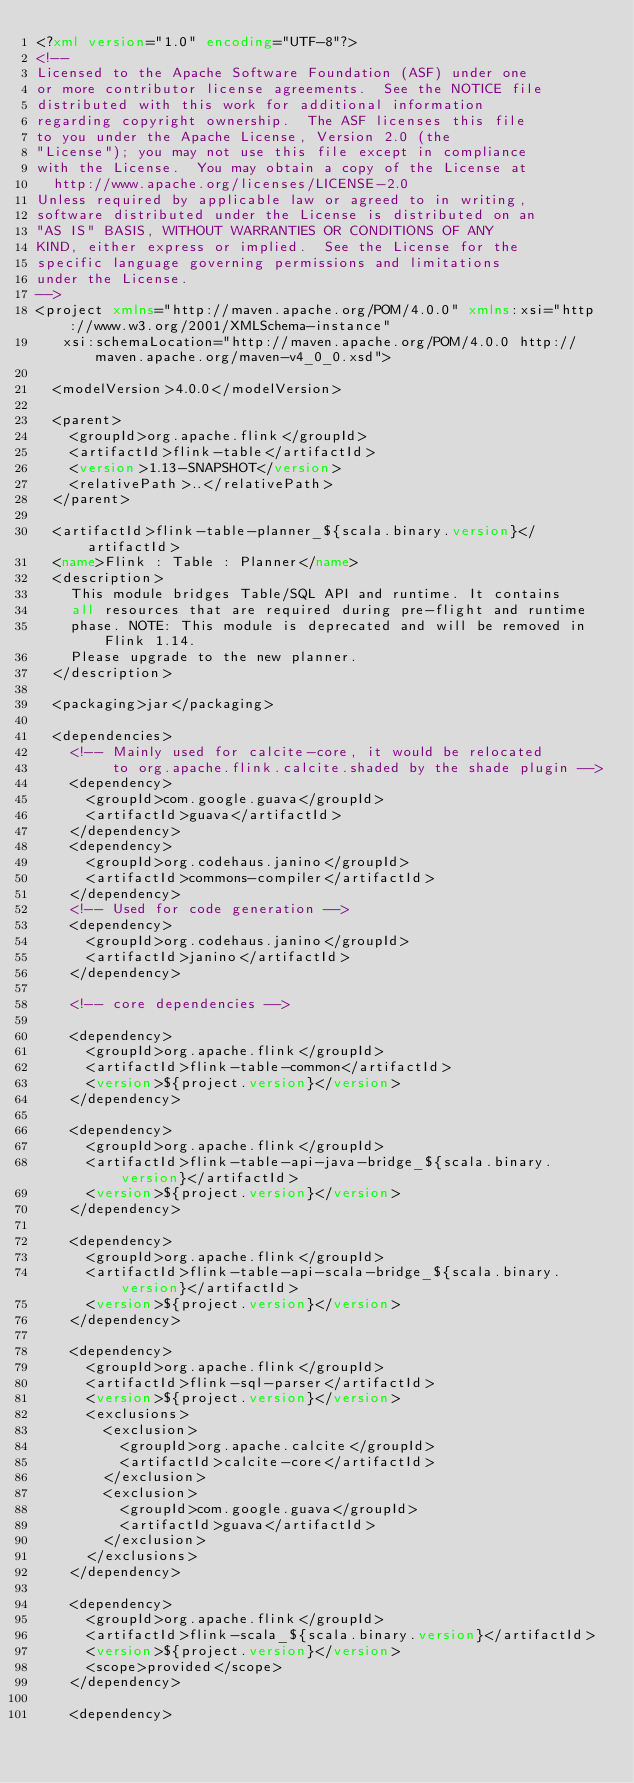<code> <loc_0><loc_0><loc_500><loc_500><_XML_><?xml version="1.0" encoding="UTF-8"?>
<!--
Licensed to the Apache Software Foundation (ASF) under one
or more contributor license agreements.  See the NOTICE file
distributed with this work for additional information
regarding copyright ownership.  The ASF licenses this file
to you under the Apache License, Version 2.0 (the
"License"); you may not use this file except in compliance
with the License.  You may obtain a copy of the License at
  http://www.apache.org/licenses/LICENSE-2.0
Unless required by applicable law or agreed to in writing,
software distributed under the License is distributed on an
"AS IS" BASIS, WITHOUT WARRANTIES OR CONDITIONS OF ANY
KIND, either express or implied.  See the License for the
specific language governing permissions and limitations
under the License.
-->
<project xmlns="http://maven.apache.org/POM/4.0.0" xmlns:xsi="http://www.w3.org/2001/XMLSchema-instance"
	 xsi:schemaLocation="http://maven.apache.org/POM/4.0.0 http://maven.apache.org/maven-v4_0_0.xsd">

	<modelVersion>4.0.0</modelVersion>

	<parent>
		<groupId>org.apache.flink</groupId>
		<artifactId>flink-table</artifactId>
		<version>1.13-SNAPSHOT</version>
		<relativePath>..</relativePath>
	</parent>

	<artifactId>flink-table-planner_${scala.binary.version}</artifactId>
	<name>Flink : Table : Planner</name>
	<description>
		This module bridges Table/SQL API and runtime. It contains
		all resources that are required during pre-flight and runtime
		phase. NOTE: This module is deprecated and will be removed in Flink 1.14.
		Please upgrade to the new planner.
	</description>

	<packaging>jar</packaging>

	<dependencies>
		<!-- Mainly used for calcite-core, it would be relocated
		     to org.apache.flink.calcite.shaded by the shade plugin -->
		<dependency>
			<groupId>com.google.guava</groupId>
			<artifactId>guava</artifactId>
		</dependency>
		<dependency>
			<groupId>org.codehaus.janino</groupId>
			<artifactId>commons-compiler</artifactId>
		</dependency>
		<!-- Used for code generation -->
		<dependency>
			<groupId>org.codehaus.janino</groupId>
			<artifactId>janino</artifactId>
		</dependency>

		<!-- core dependencies -->

		<dependency>
			<groupId>org.apache.flink</groupId>
			<artifactId>flink-table-common</artifactId>
			<version>${project.version}</version>
		</dependency>

		<dependency>
			<groupId>org.apache.flink</groupId>
			<artifactId>flink-table-api-java-bridge_${scala.binary.version}</artifactId>
			<version>${project.version}</version>
		</dependency>

		<dependency>
			<groupId>org.apache.flink</groupId>
			<artifactId>flink-table-api-scala-bridge_${scala.binary.version}</artifactId>
			<version>${project.version}</version>
		</dependency>

		<dependency>
			<groupId>org.apache.flink</groupId>
			<artifactId>flink-sql-parser</artifactId>
			<version>${project.version}</version>
			<exclusions>
				<exclusion>
					<groupId>org.apache.calcite</groupId>
					<artifactId>calcite-core</artifactId>
				</exclusion>
				<exclusion>
					<groupId>com.google.guava</groupId>
					<artifactId>guava</artifactId>
				</exclusion>
			</exclusions>
		</dependency>

		<dependency>
			<groupId>org.apache.flink</groupId>
			<artifactId>flink-scala_${scala.binary.version}</artifactId>
			<version>${project.version}</version>
			<scope>provided</scope>
		</dependency>

		<dependency></code> 